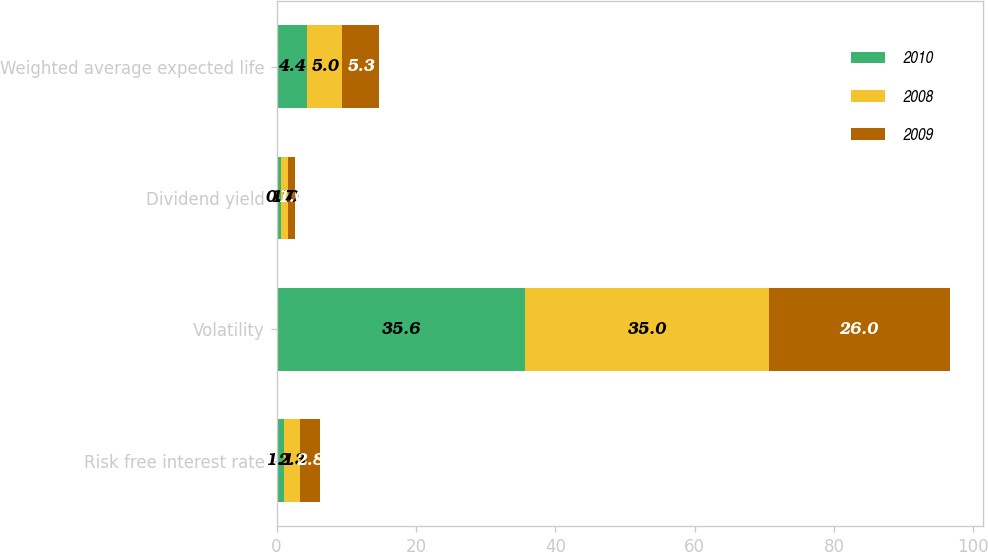Convert chart to OTSL. <chart><loc_0><loc_0><loc_500><loc_500><stacked_bar_chart><ecel><fcel>Risk free interest rate<fcel>Volatility<fcel>Dividend yield<fcel>Weighted average expected life<nl><fcel>2010<fcel>1.1<fcel>35.6<fcel>0.7<fcel>4.4<nl><fcel>2008<fcel>2.3<fcel>35<fcel>1<fcel>5<nl><fcel>2009<fcel>2.8<fcel>26<fcel>1<fcel>5.3<nl></chart> 